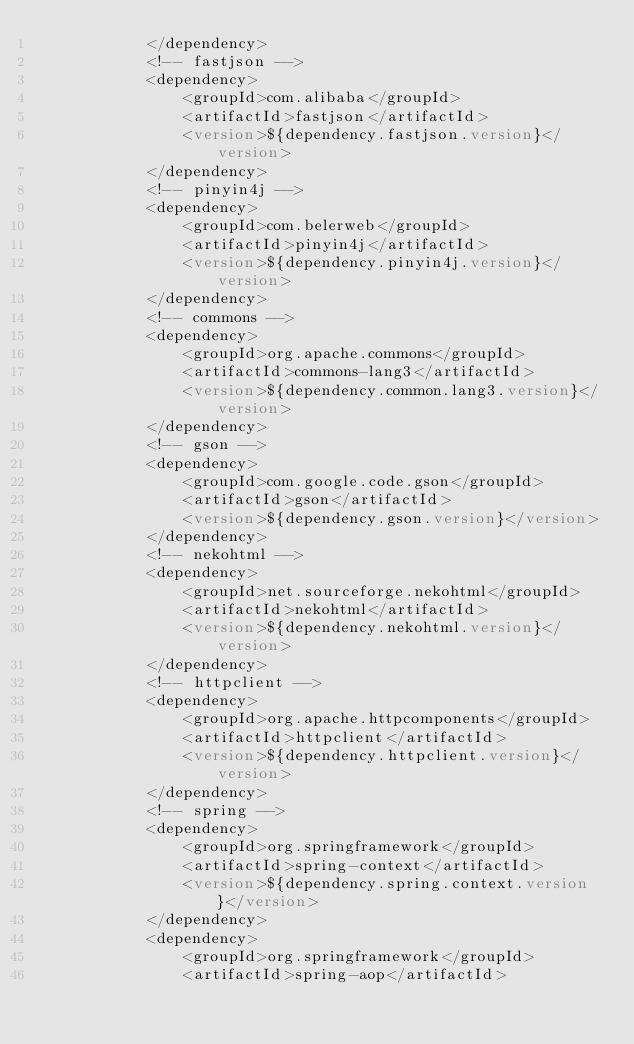<code> <loc_0><loc_0><loc_500><loc_500><_XML_>            </dependency>
            <!-- fastjson -->
            <dependency>
                <groupId>com.alibaba</groupId>
                <artifactId>fastjson</artifactId>
                <version>${dependency.fastjson.version}</version>
            </dependency>
            <!-- pinyin4j -->
            <dependency>
                <groupId>com.belerweb</groupId>
                <artifactId>pinyin4j</artifactId>
                <version>${dependency.pinyin4j.version}</version>
            </dependency>
            <!-- commons -->
            <dependency>
                <groupId>org.apache.commons</groupId>
                <artifactId>commons-lang3</artifactId>
                <version>${dependency.common.lang3.version}</version>
            </dependency>
            <!-- gson -->
            <dependency>
                <groupId>com.google.code.gson</groupId>
                <artifactId>gson</artifactId>
                <version>${dependency.gson.version}</version>
            </dependency>
            <!-- nekohtml -->
            <dependency>
                <groupId>net.sourceforge.nekohtml</groupId>
                <artifactId>nekohtml</artifactId>
                <version>${dependency.nekohtml.version}</version>
            </dependency>
            <!-- httpclient -->
            <dependency>
                <groupId>org.apache.httpcomponents</groupId>
                <artifactId>httpclient</artifactId>
                <version>${dependency.httpclient.version}</version>
            </dependency>
            <!-- spring -->
            <dependency>
                <groupId>org.springframework</groupId>
                <artifactId>spring-context</artifactId>
                <version>${dependency.spring.context.version}</version>
            </dependency>
            <dependency>
                <groupId>org.springframework</groupId>
                <artifactId>spring-aop</artifactId></code> 